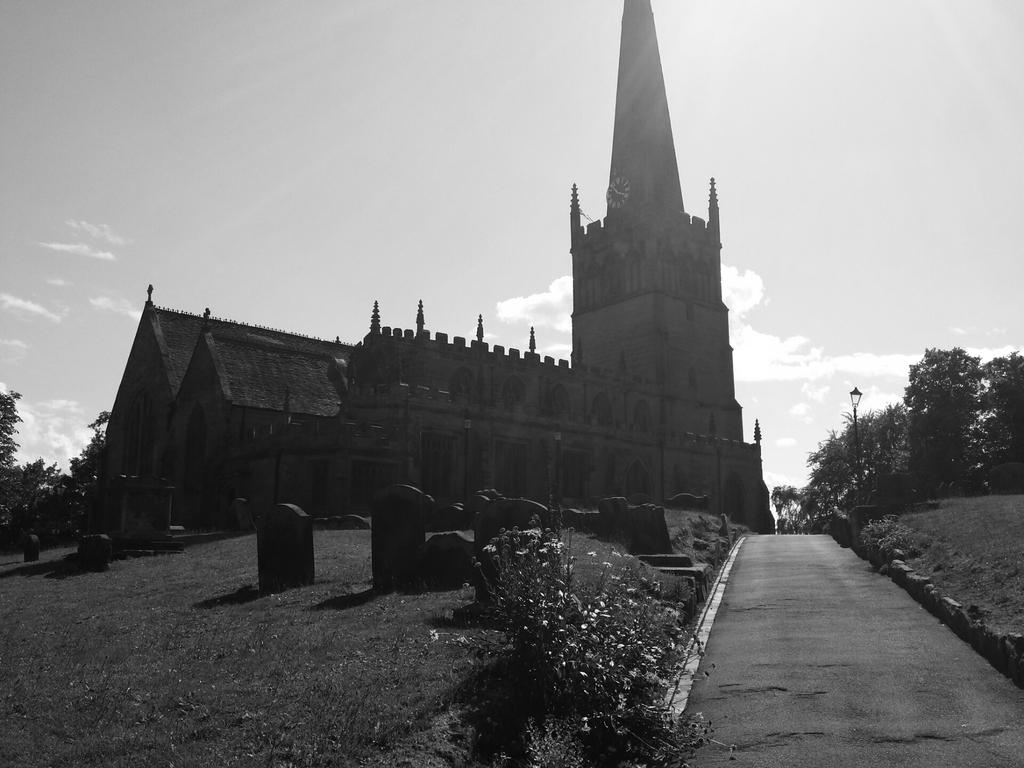What is the color scheme of the image? The image is black and white. What type of structure can be seen in the image? There is a light pole in the image. What type of natural elements are present in the image? There are trees and plants in the image. What type of man-made structures are present in the image? There are memorial stones and a building in the image. What type of timekeeping device is present in the image? There is a clock in the image. What is the weather like in the image? The sky is cloudy in the image. What type of verse can be seen written on the memorial stones in the image? There is no verse written on the memorial stones in the image; they are simply stones. What type of sticks are used to support the plants in the image? There are no sticks visible in the image; the plants are not supported by any sticks. 